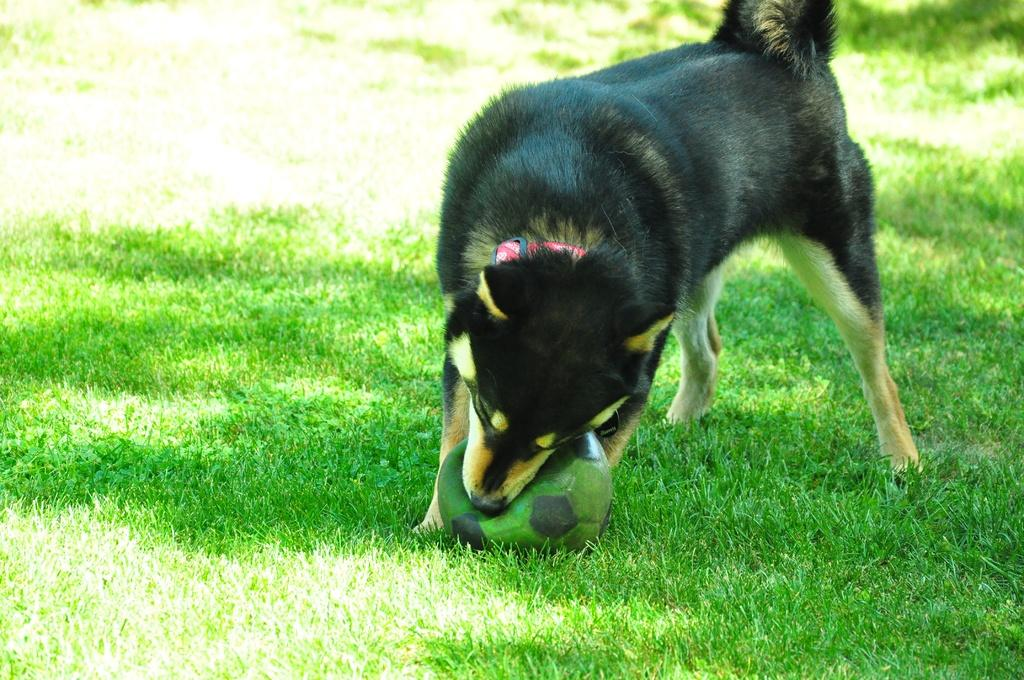What animal is present in the image? There is a dog in the image. What is the dog holding in the image? The dog is holding a ball. What type of surface is the ball on? The ball is on the grass. What type of instrument is the dog playing in the image? There is no instrument present in the image, and the dog is not playing any instrument. How many women are visible in the image? There are no women present in the image; it features a dog holding a ball on the grass. 